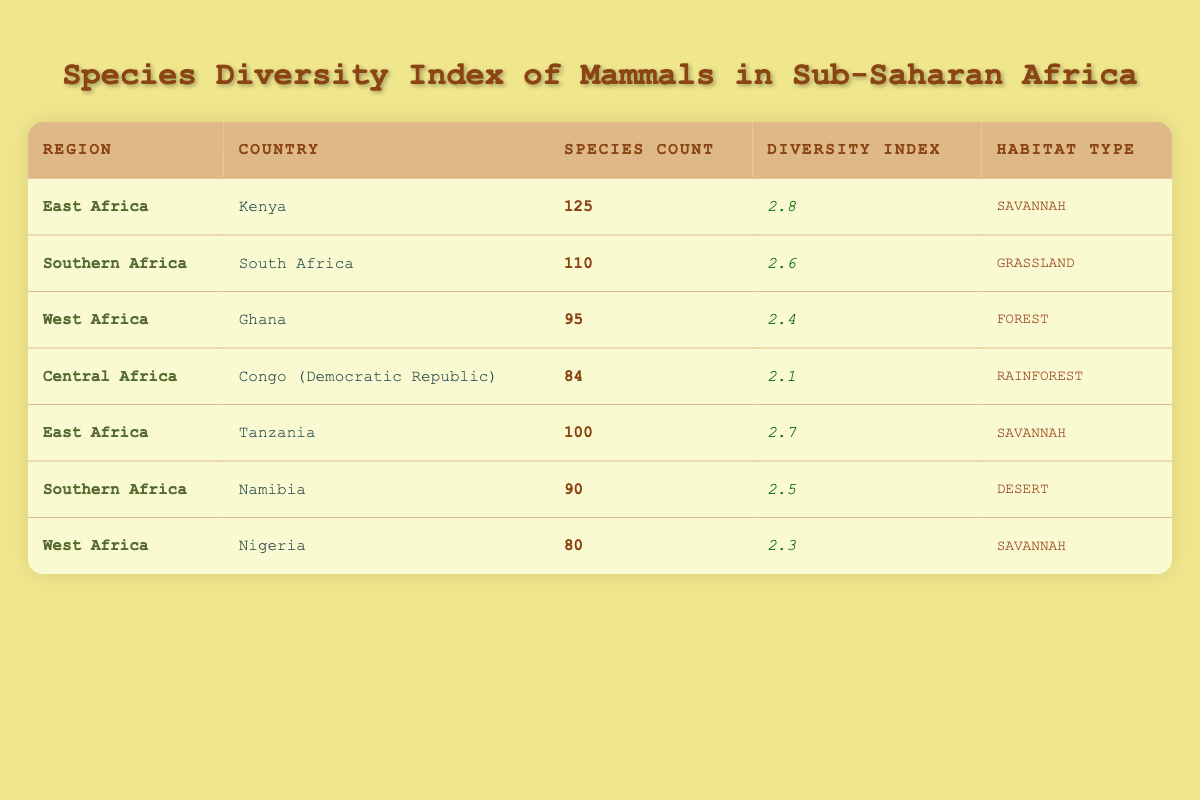What is the diversity index of Kenya? The table lists Kenya under East Africa, showing a diversity index of 2.8.
Answer: 2.8 How many species are found in Tanzania? Looking at the row for Tanzania, it shows that there are 100 species.
Answer: 100 Is the diversity index higher in South Africa than in Ghana? South Africa has a diversity index of 2.6 while Ghana has 2.4. Therefore, South Africa's diversity index is higher.
Answer: Yes Which country has the lowest species count, and what is that count? The lowest species count in the table is found in Nigeria with a count of 80 species.
Answer: Nigeria, 80 What is the average diversity index for the countries in West Africa? The diversity indexes for West Africa are 2.4 (Ghana) and 2.3 (Nigeria). To find the average, add these values (2.4 + 2.3 = 4.7) and divide by the number of countries (4.7 / 2 = 2.35).
Answer: 2.35 Which region has the highest species count, and what is that count? By comparing the species counts: East Africa has 125 (Kenya) and 100 (Tanzania), Southern Africa has 110 (South Africa) and 90 (Namibia), West Africa has 95 (Ghana) and 80 (Nigeria), and Central Africa has 84 (Congo). The highest is 125 in East Africa (Kenya).
Answer: East Africa, 125 Is the habitat type for both countries in East Africa the same? Looking at the table, both Kenya and Tanzania are categorized as "Savannah," confirming they share the same habitat type.
Answer: Yes How many more species does South Africa have compared to Namibia? South Africa has 110 species and Namibia has 90. The difference is calculated as 110 - 90 = 20.
Answer: 20 Which region has the highest average species count based on the available data? West Africa includes Ghana's 95 and Nigeria's 80 (average = 87.5). East Africa has 125 and 100 (average = 112.5). Southern Africa has 110 and 90 (average = 100). Central Africa has 84. East Africa has the largest average at 112.5.
Answer: East Africa, 112.5 